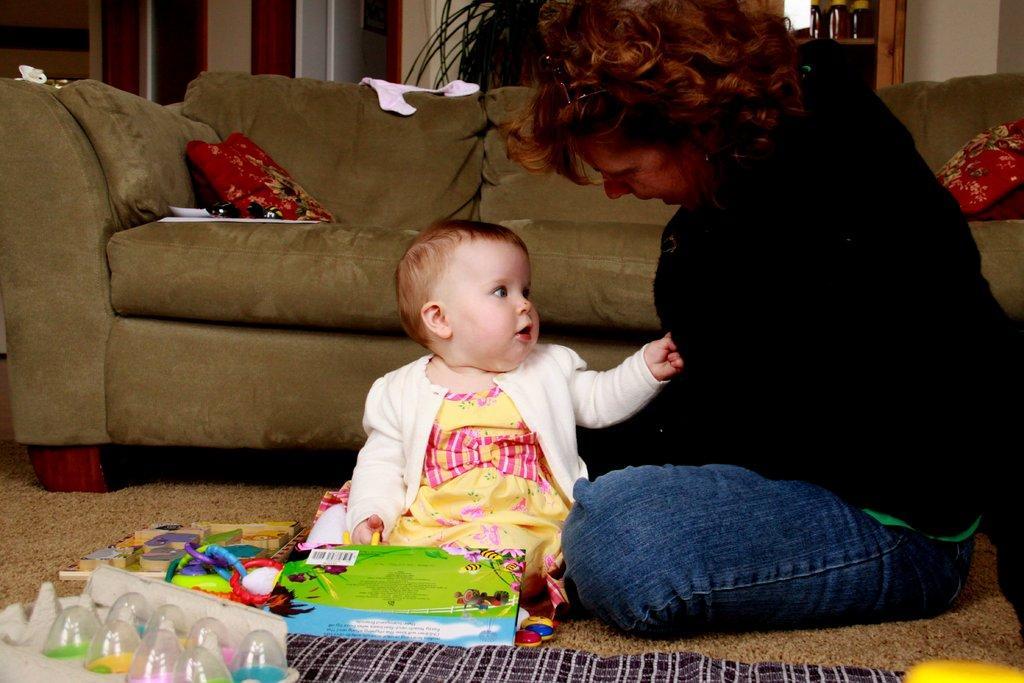In one or two sentences, can you explain what this image depicts? At the bottom of the image on the floor there is a lady with black jacket is sitting. Beside her there is a baby with white jacket, yellow and pink frock. In front of the baby there are few toys. Behind them there is a sofa with pillows and few white color items. In the background there is a wall. 